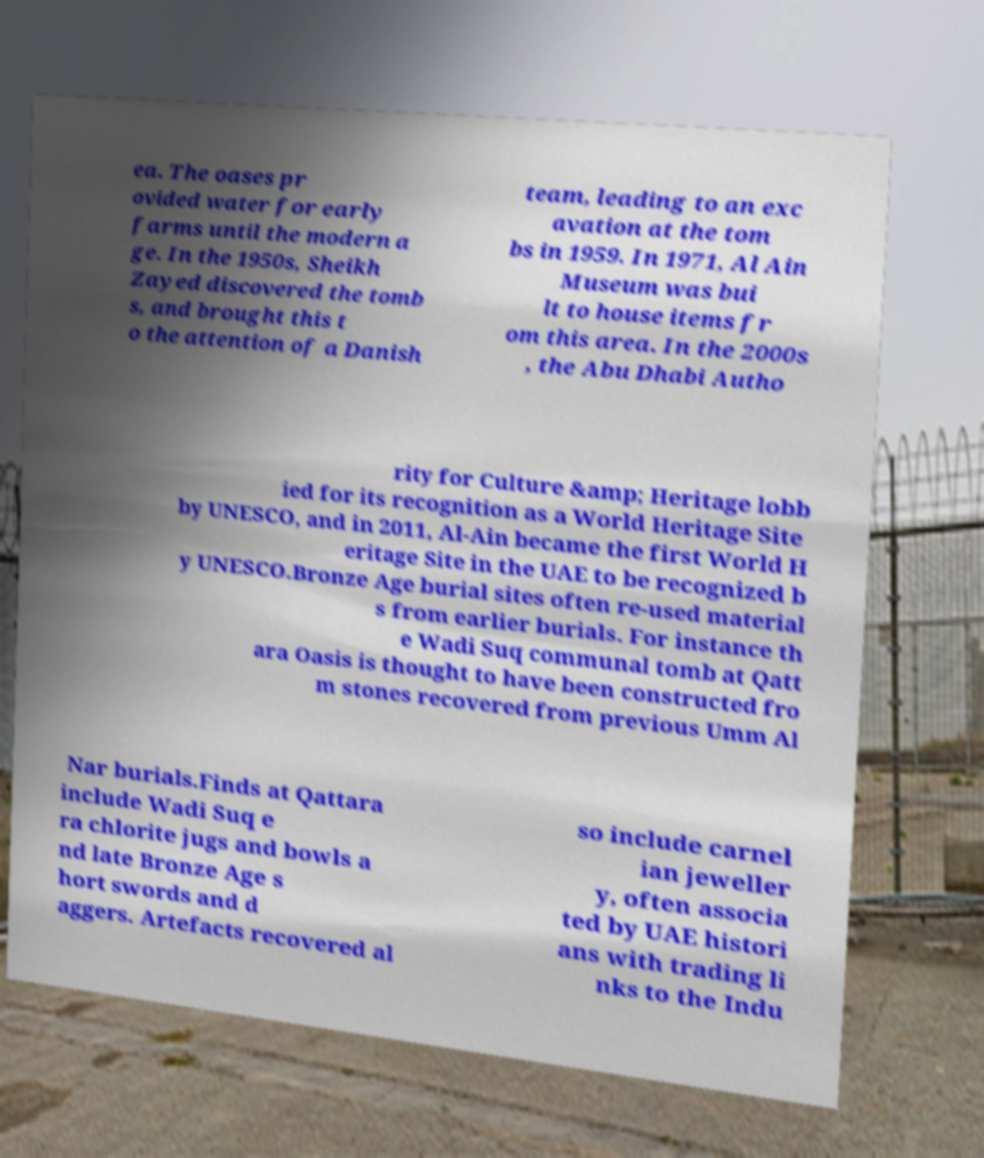Please identify and transcribe the text found in this image. ea. The oases pr ovided water for early farms until the modern a ge. In the 1950s, Sheikh Zayed discovered the tomb s, and brought this t o the attention of a Danish team, leading to an exc avation at the tom bs in 1959. In 1971, Al Ain Museum was bui lt to house items fr om this area. In the 2000s , the Abu Dhabi Autho rity for Culture &amp; Heritage lobb ied for its recognition as a World Heritage Site by UNESCO, and in 2011, Al-Ain became the first World H eritage Site in the UAE to be recognized b y UNESCO.Bronze Age burial sites often re-used material s from earlier burials. For instance th e Wadi Suq communal tomb at Qatt ara Oasis is thought to have been constructed fro m stones recovered from previous Umm Al Nar burials.Finds at Qattara include Wadi Suq e ra chlorite jugs and bowls a nd late Bronze Age s hort swords and d aggers. Artefacts recovered al so include carnel ian jeweller y, often associa ted by UAE histori ans with trading li nks to the Indu 